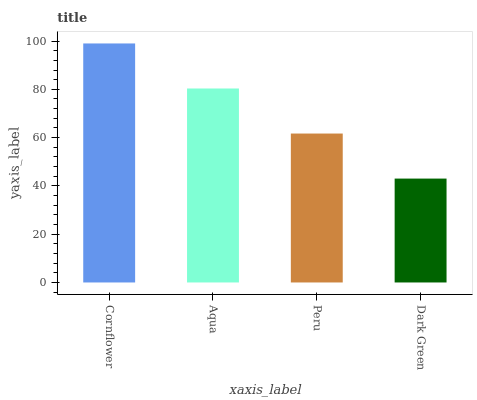Is Dark Green the minimum?
Answer yes or no. Yes. Is Cornflower the maximum?
Answer yes or no. Yes. Is Aqua the minimum?
Answer yes or no. No. Is Aqua the maximum?
Answer yes or no. No. Is Cornflower greater than Aqua?
Answer yes or no. Yes. Is Aqua less than Cornflower?
Answer yes or no. Yes. Is Aqua greater than Cornflower?
Answer yes or no. No. Is Cornflower less than Aqua?
Answer yes or no. No. Is Aqua the high median?
Answer yes or no. Yes. Is Peru the low median?
Answer yes or no. Yes. Is Dark Green the high median?
Answer yes or no. No. Is Cornflower the low median?
Answer yes or no. No. 